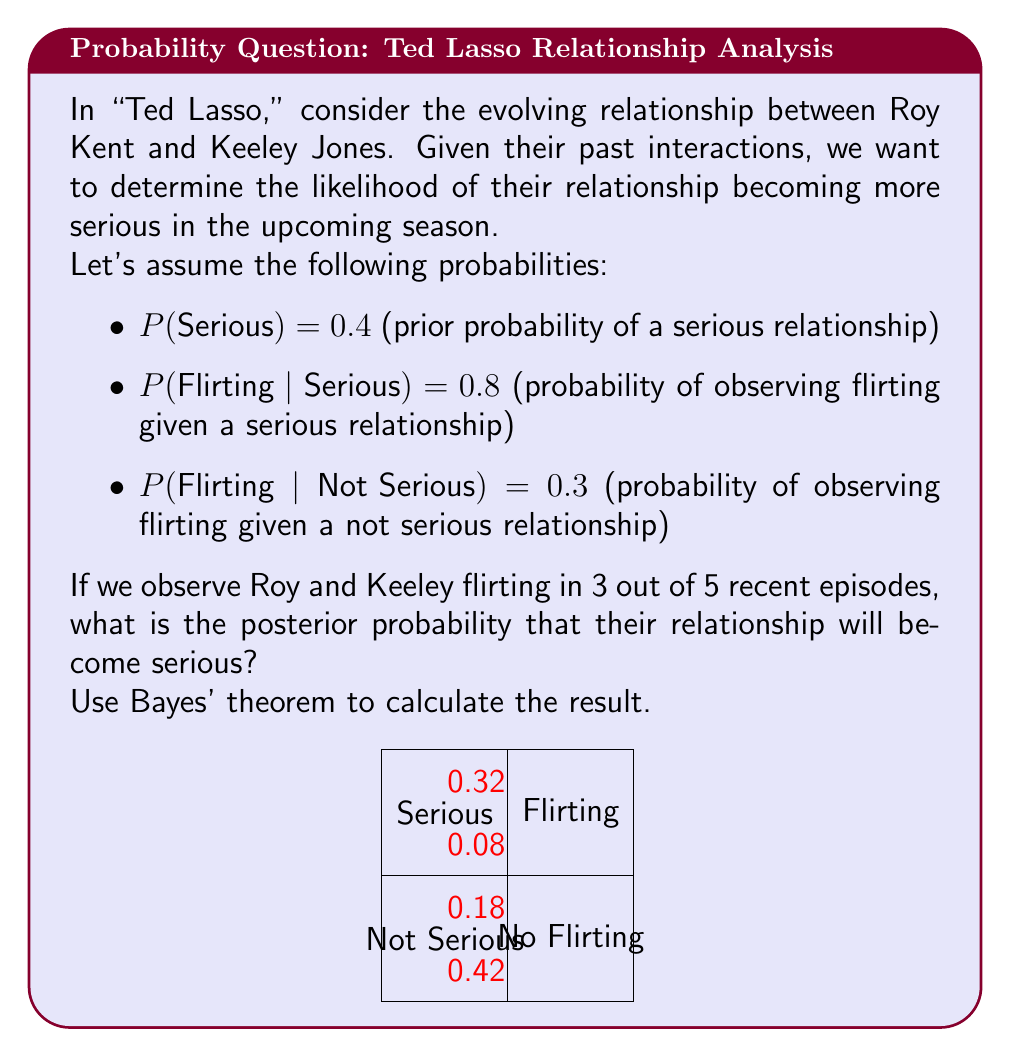Give your solution to this math problem. Let's approach this step-by-step using Bayes' theorem:

1) First, we need to calculate the likelihood of observing the data (3 flirting episodes out of 5) given each hypothesis:

   P(Data | Serious) = $${5 \choose 3} (0.8)^3 (0.2)^2 = 0.2048$$
   P(Data | Not Serious) = $${5 \choose 3} (0.3)^3 (0.7)^2 = 0.0567$$

2) Now we can apply Bayes' theorem:

   $$P(Serious | Data) = \frac{P(Data | Serious) \cdot P(Serious)}{P(Data)}$$

3) We can expand P(Data) using the law of total probability:

   $$P(Data) = P(Data | Serious) \cdot P(Serious) + P(Data | Not Serious) \cdot P(Not Serious)$$
   $$= 0.2048 \cdot 0.4 + 0.0567 \cdot 0.6 = 0.08192 + 0.03402 = 0.11594$$

4) Now we can calculate the posterior probability:

   $$P(Serious | Data) = \frac{0.2048 \cdot 0.4}{0.11594} = \frac{0.08192}{0.11594} \approx 0.7066$$

Therefore, given the observed flirting in 3 out of 5 recent episodes, the posterior probability that Roy and Keeley's relationship will become serious is approximately 0.7066 or 70.66%.
Answer: 0.7066 